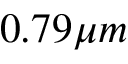Convert formula to latex. <formula><loc_0><loc_0><loc_500><loc_500>0 . 7 9 \mu m</formula> 